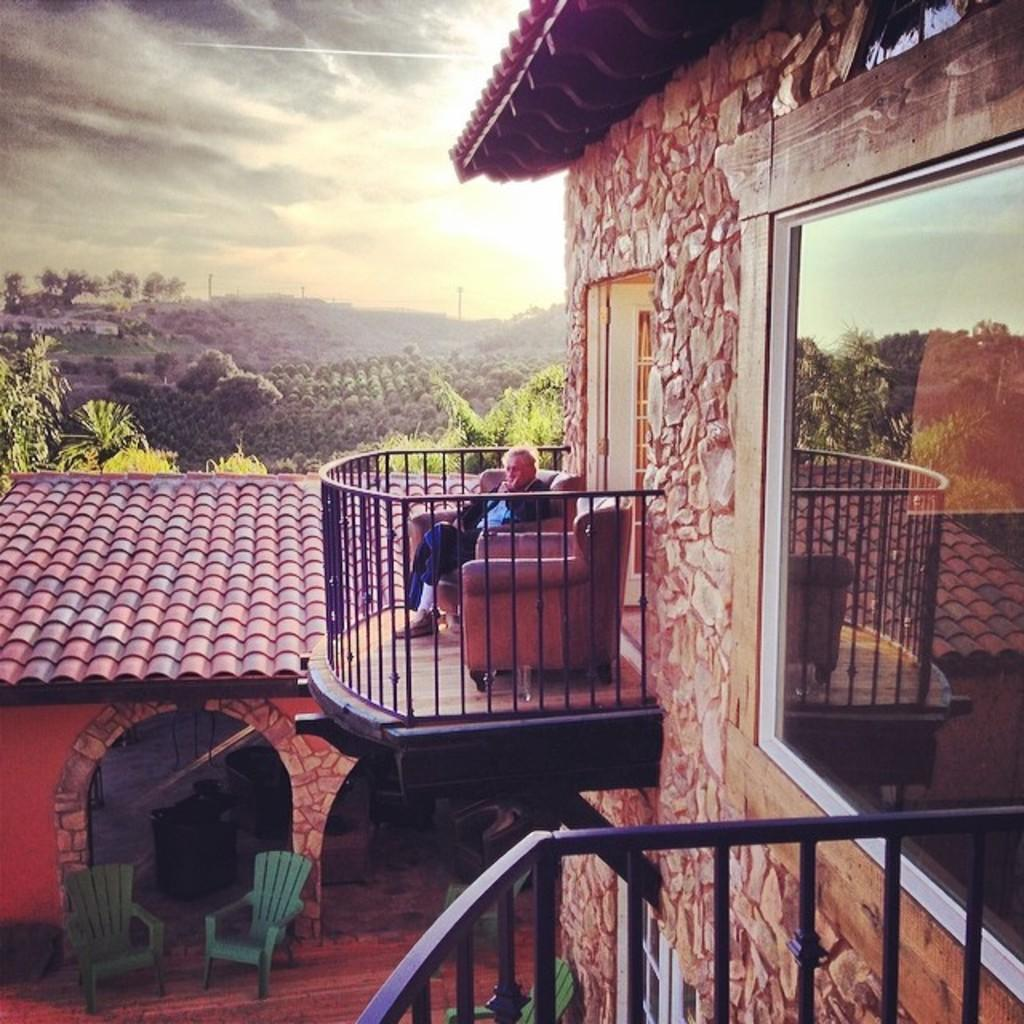What is the main subject of the image? The main subject of the image is an old man sitting on a sofa. Where is the sofa located? The sofa is located in a veranda. What other furniture can be seen in the image? There are chairs at the bottom of the image. What can be seen in the background of the image? There are trees in the background of the image. What is visible at the top of the image? The sky is visible at the top of the image. How many spies are hiding behind the trees in the image? There are no spies present in the image; it only features an old man sitting on a sofa, chairs, trees, and the sky. What type of toy can be seen on the old man's lap in the image? There is no toy visible on the old man's lap in the image. 